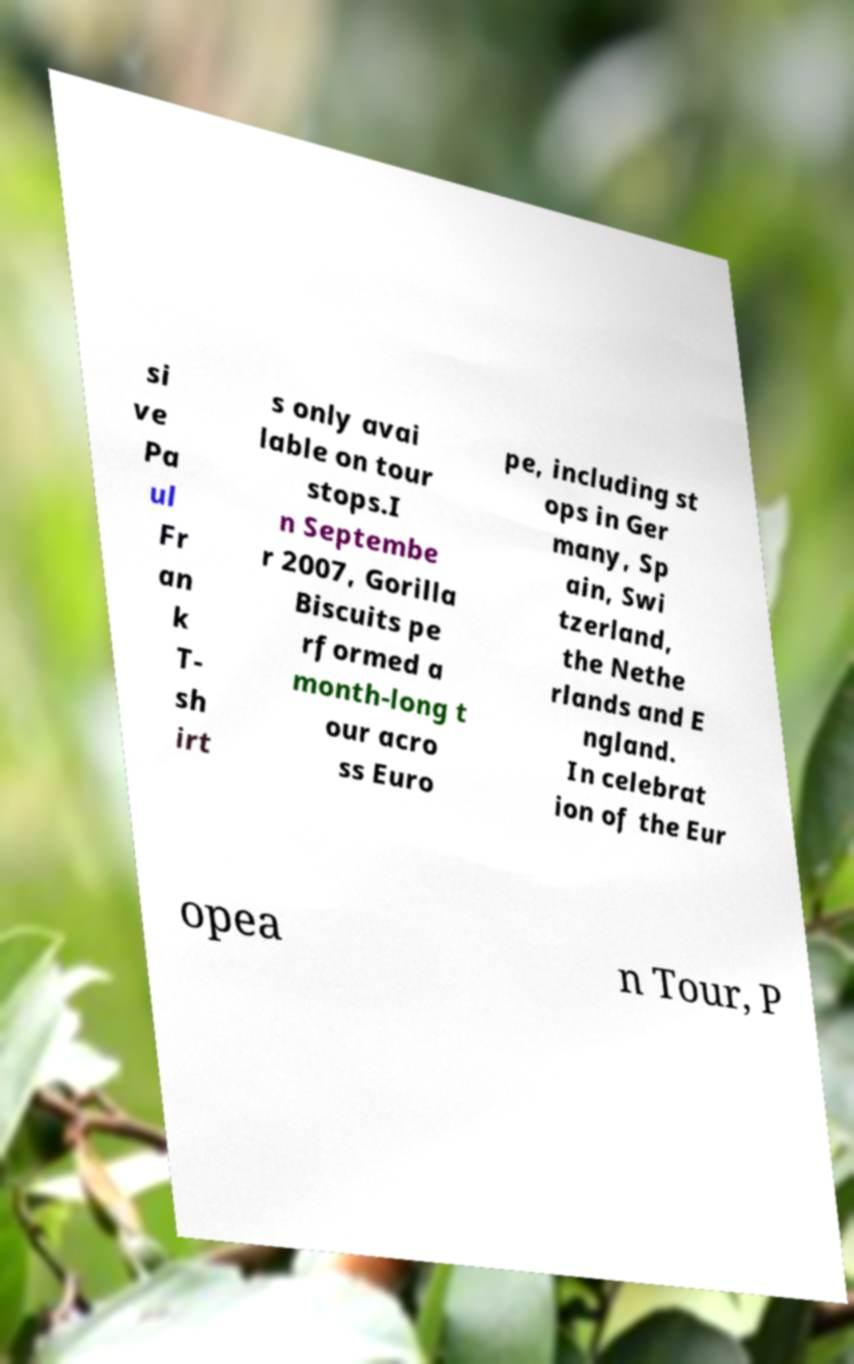Can you read and provide the text displayed in the image?This photo seems to have some interesting text. Can you extract and type it out for me? si ve Pa ul Fr an k T- sh irt s only avai lable on tour stops.I n Septembe r 2007, Gorilla Biscuits pe rformed a month-long t our acro ss Euro pe, including st ops in Ger many, Sp ain, Swi tzerland, the Nethe rlands and E ngland. In celebrat ion of the Eur opea n Tour, P 